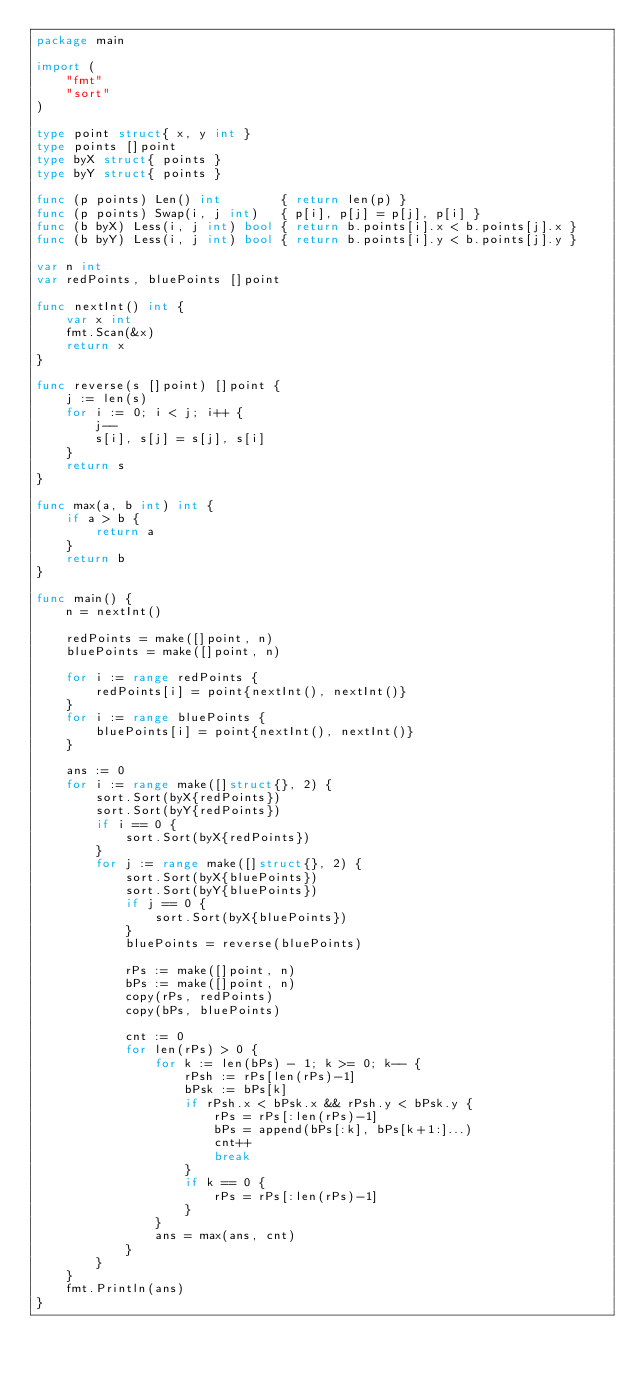Convert code to text. <code><loc_0><loc_0><loc_500><loc_500><_Go_>package main

import (
	"fmt"
	"sort"
)

type point struct{ x, y int }
type points []point
type byX struct{ points }
type byY struct{ points }

func (p points) Len() int        { return len(p) }
func (p points) Swap(i, j int)   { p[i], p[j] = p[j], p[i] }
func (b byX) Less(i, j int) bool { return b.points[i].x < b.points[j].x }
func (b byY) Less(i, j int) bool { return b.points[i].y < b.points[j].y }

var n int
var redPoints, bluePoints []point

func nextInt() int {
	var x int
	fmt.Scan(&x)
	return x
}

func reverse(s []point) []point {
	j := len(s)
	for i := 0; i < j; i++ {
		j--
		s[i], s[j] = s[j], s[i]
	}
	return s
}

func max(a, b int) int {
	if a > b {
		return a
	}
	return b
}

func main() {
	n = nextInt()

	redPoints = make([]point, n)
	bluePoints = make([]point, n)

	for i := range redPoints {
		redPoints[i] = point{nextInt(), nextInt()}
	}
	for i := range bluePoints {
		bluePoints[i] = point{nextInt(), nextInt()}
	}

	ans := 0
	for i := range make([]struct{}, 2) {
		sort.Sort(byX{redPoints})
		sort.Sort(byY{redPoints})
		if i == 0 {
			sort.Sort(byX{redPoints})
		}
		for j := range make([]struct{}, 2) {
			sort.Sort(byX{bluePoints})
			sort.Sort(byY{bluePoints})
			if j == 0 {
				sort.Sort(byX{bluePoints})
			}
			bluePoints = reverse(bluePoints)

			rPs := make([]point, n)
			bPs := make([]point, n)
			copy(rPs, redPoints)
			copy(bPs, bluePoints)

			cnt := 0
			for len(rPs) > 0 {
				for k := len(bPs) - 1; k >= 0; k-- {
					rPsh := rPs[len(rPs)-1]
					bPsk := bPs[k]
					if rPsh.x < bPsk.x && rPsh.y < bPsk.y {
						rPs = rPs[:len(rPs)-1]
						bPs = append(bPs[:k], bPs[k+1:]...)
						cnt++
						break
					}
					if k == 0 {
						rPs = rPs[:len(rPs)-1]
					}
				}
				ans = max(ans, cnt)
			}
		}
	}
	fmt.Println(ans)
}
</code> 